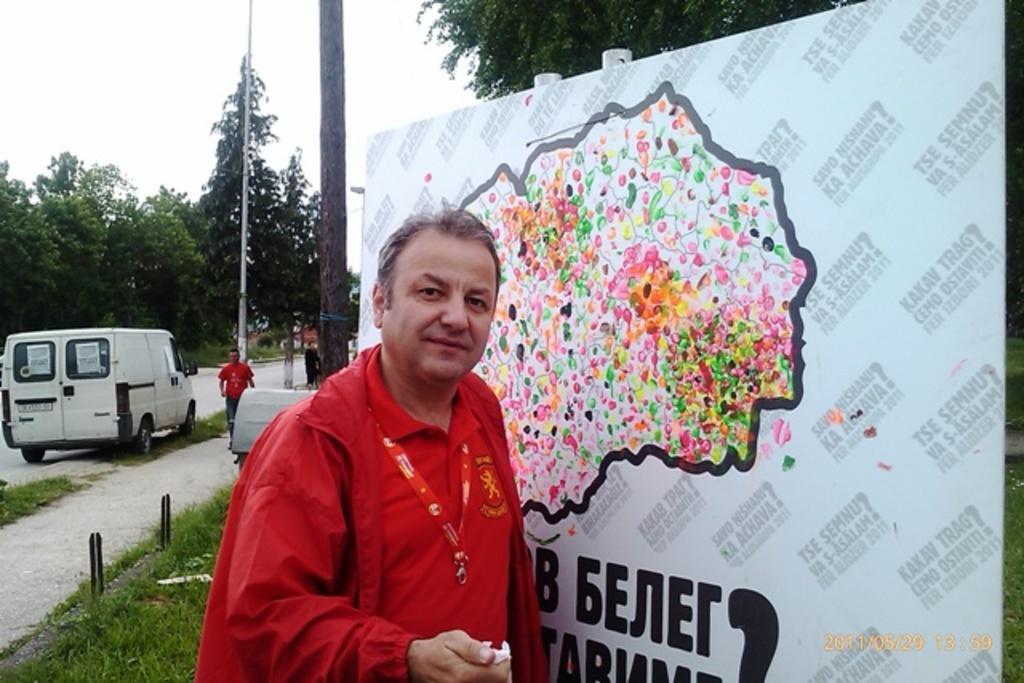Could you give a brief overview of what you see in this image? In this image, we can see a person in front of the board. There are poles in the middle of the image. There is a vehicle and some trees on the left side of the image. There is a branch at the top of the image. There is a grass on the ground. There is a sky in the top left of the image. 